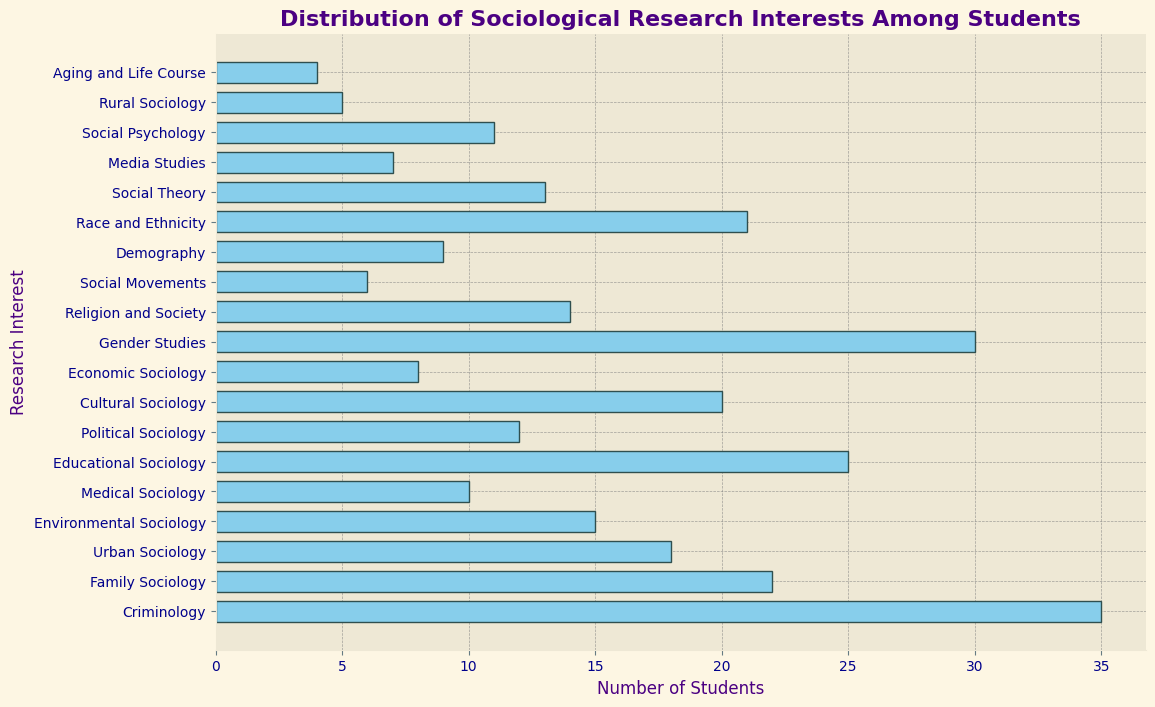What are the top three most popular research interests among students? Identify the bars with the highest values. The three highest bars are for Criminology (35), Gender Studies (30), and Educational Sociology (25).
Answer: Criminology, Gender Studies, Educational Sociology Which research interest has the smallest number of students? Locate the shortest bar on the histogram. The shortest bar corresponds to Aging and Life Course with 4 students.
Answer: Aging and Life Course How many more students are interested in Criminology compared to Urban Sociology? Look at the bars for Criminology and Urban Sociology. Criminology has 35 students, and Urban Sociology has 18 students. Calculate the difference: 35 - 18 = 17.
Answer: 17 What is the total number of students interested in Environmental Sociology, Medical Sociology, and Political Sociology combined? Sum the number of students for these categories: Environmental Sociology (15), Medical Sociology (10), and Political Sociology (12). The total is 15 + 10 + 12 = 37.
Answer: 37 Which research interest group has more students: Cultural Sociology or Religion and Society? Compare the lengths of the bars for Cultural Sociology and Religion and Society. Cultural Sociology has 20 students, and Religion and Society has 14 students.
Answer: Cultural Sociology Is the number of students interested in Social Theory greater than the number of students interested in Social Psychology? Locate and compare the bars for Social Theory and Social Psychology. Social Theory has 13 students, and Social Psychology has 11 students.
Answer: Yes How many students are interested in Social Movements and Media Studies combined, and does this number exceed the number of students interested in Criminology? Add the number of students for Social Movements (6) and Media Studies (7): 6 + 7 = 13. Compare this total to the number of students in Criminology (35).
Answer: No, it does not exceed What is the median number of students interested in the various research interests? List the numbers of students and find the middle value. Sorted list: [4, 5, 6, 7, 8, 9, 10, 11, 12, 13, 14, 15, 18, 20, 21, 22, 25, 30, 35]. The median value (middle of 19 values) is 14.
Answer: 14 Between Race and Ethnicity and Educational Sociology, which research interest has fewer students? Compare the bars for Race and Ethnicity (21 students) and Educational Sociology (25 students).
Answer: Race and Ethnicity What is the difference in the number of students between the most and least popular research interests? Identify the highest and lowest bars: Criminology (35 students) and Aging and Life Course (4 students). Calculate the difference: 35 - 4 = 31.
Answer: 31 